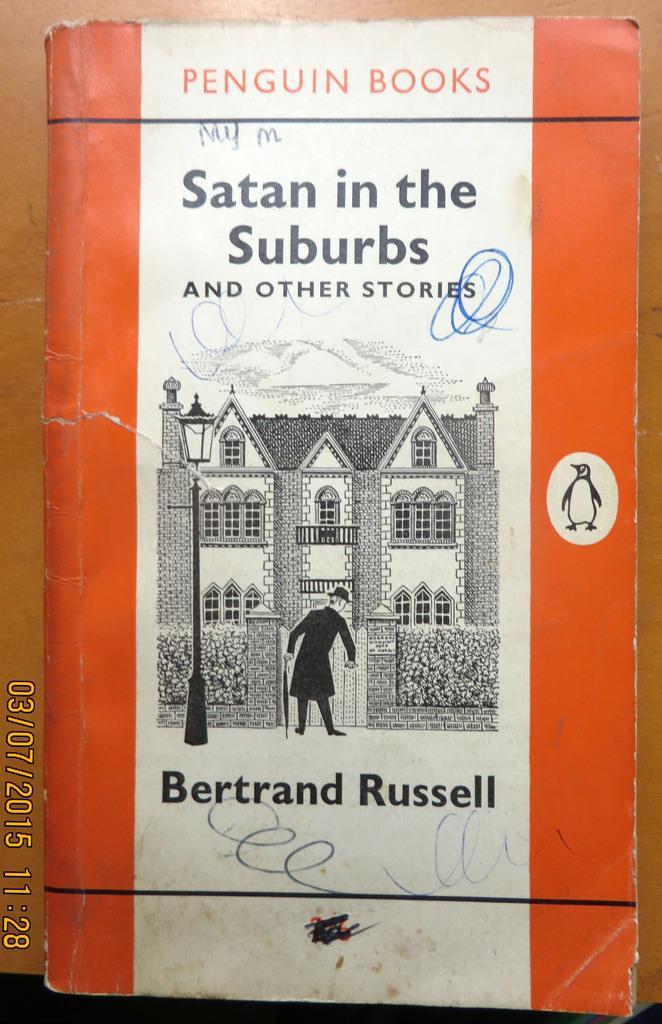What object can be seen in the image? There is a book in the image. Where is the book located? The book is placed on a surface. What can be found on the book? There is text written on the book. What idea does the woman in the image have about the book? There is no woman present in the image, so it is not possible to determine any ideas she might have about the book. 